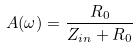Convert formula to latex. <formula><loc_0><loc_0><loc_500><loc_500>A ( \omega ) = \frac { R _ { 0 } } { Z _ { i n } + R _ { 0 } }</formula> 